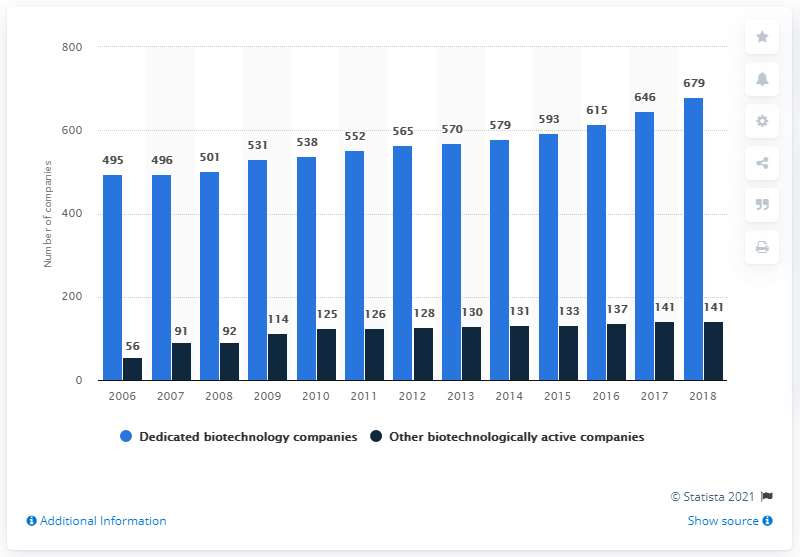What was the number of other biotechnologically active companies in Germany in 2018? In 2018, Germany hosted 141 other biotechnologically active companies, which denotes those that are not solely dedicated to biotechnology but incorporate it in their operations. 